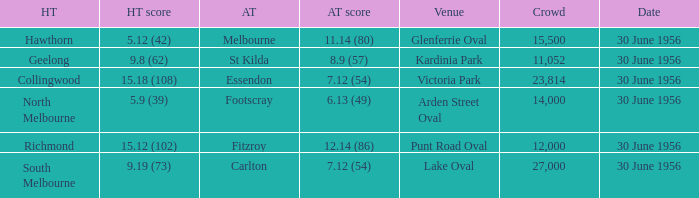What away team has a home team score of 15.18 (108)? Essendon. 